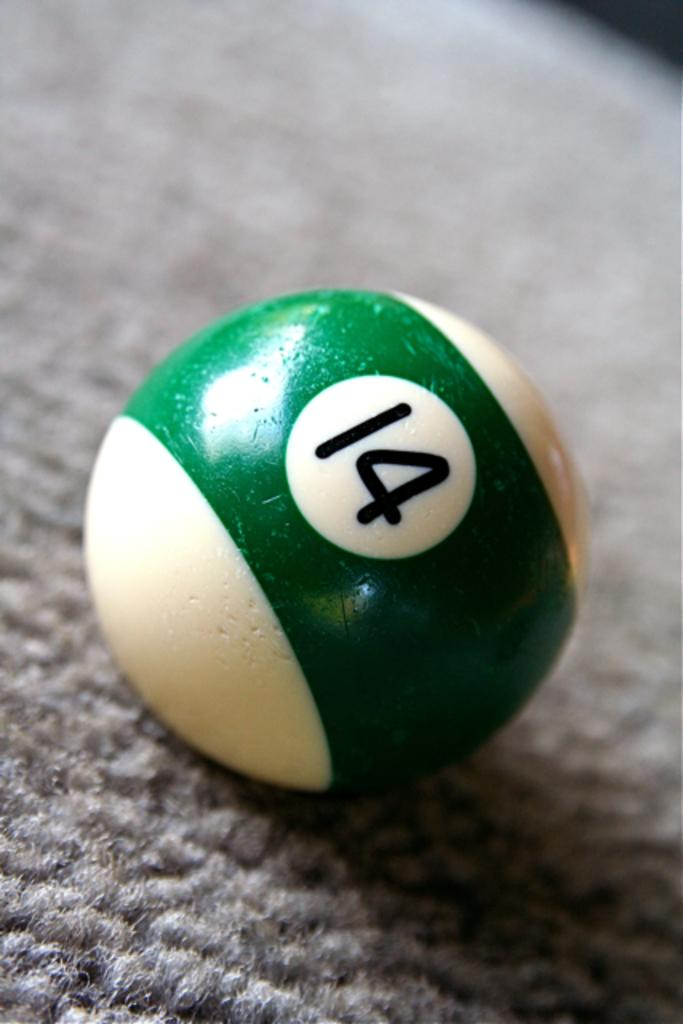<image>
Present a compact description of the photo's key features. #14 ball that is used in the game of pool. 